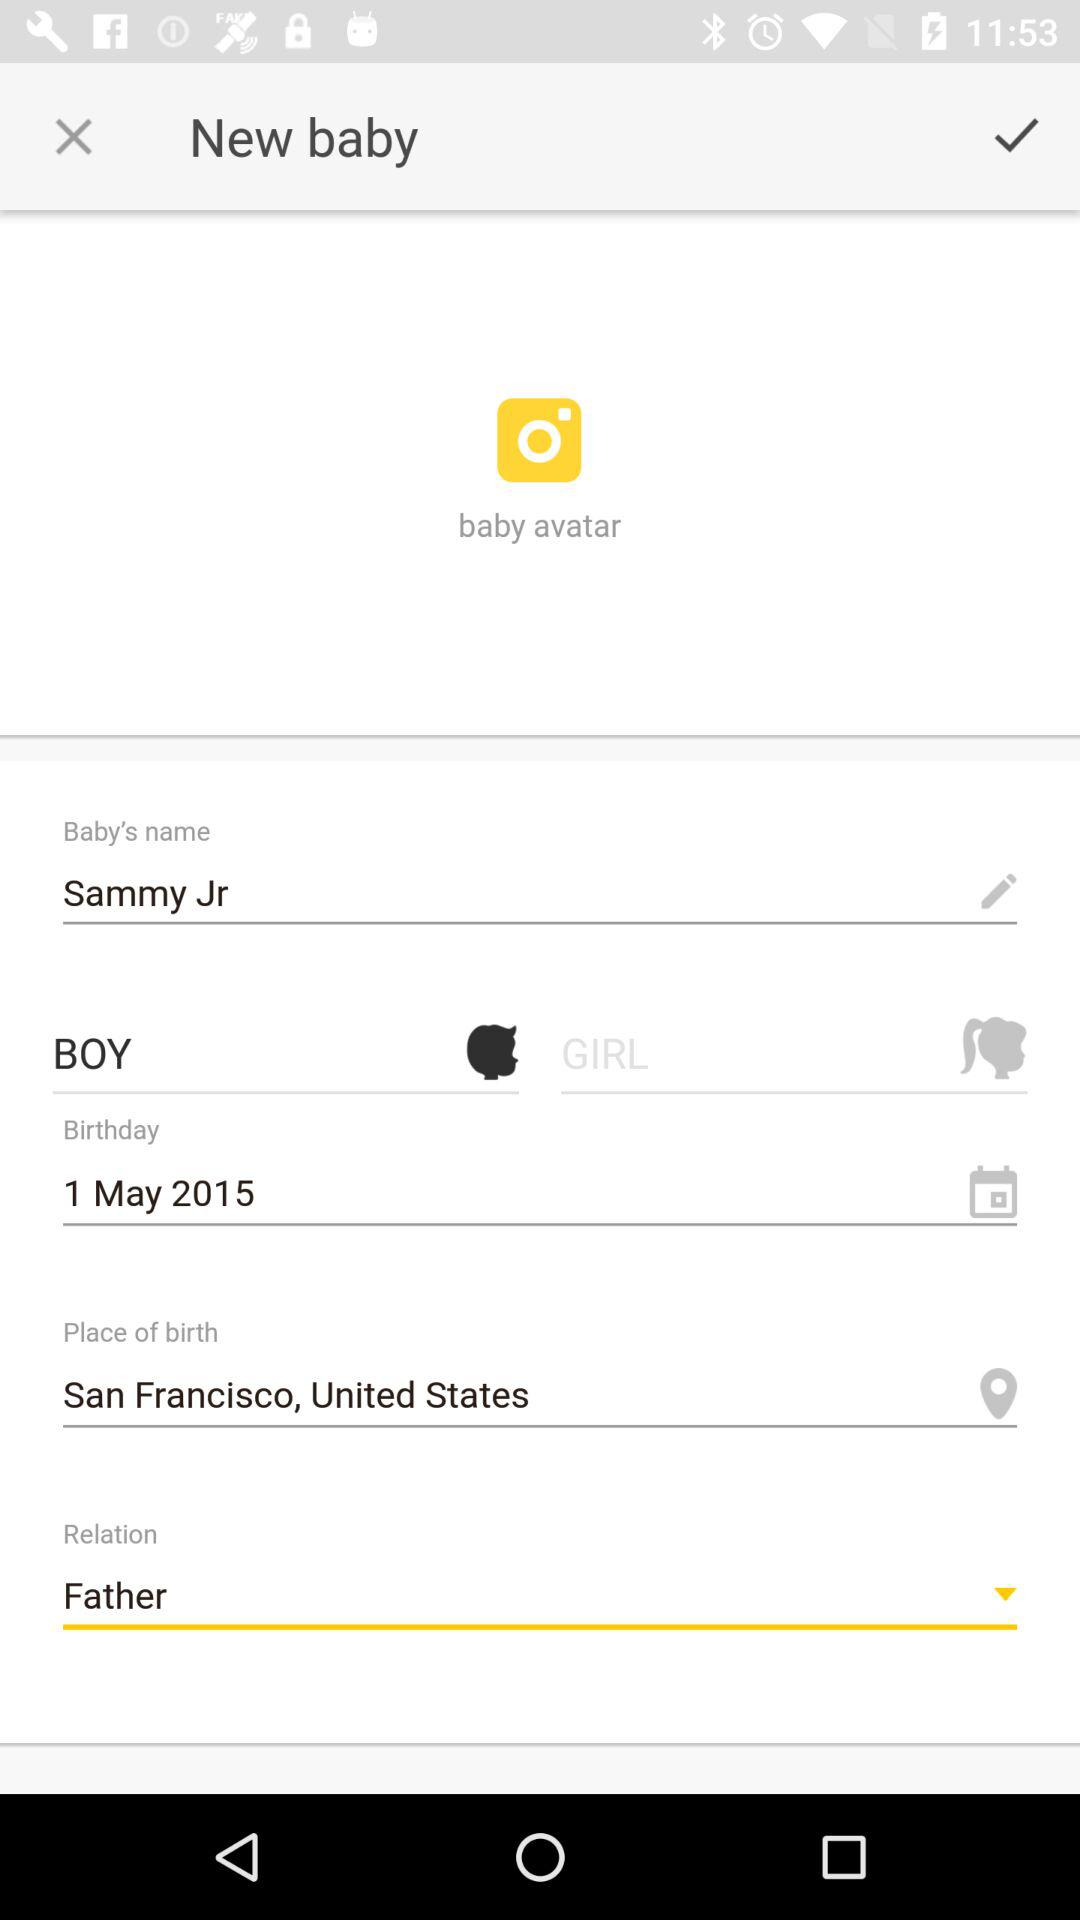What is the gender of the baby? The gender of the baby is boy. 